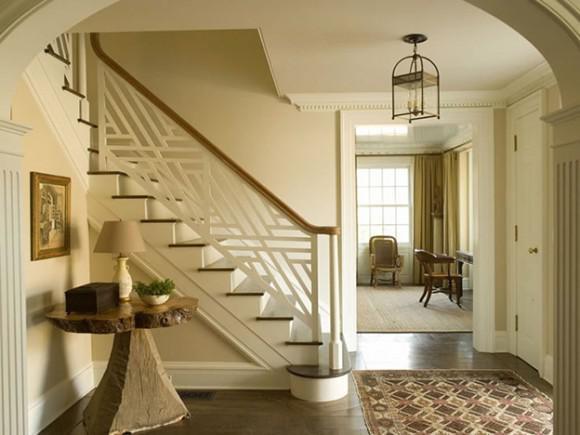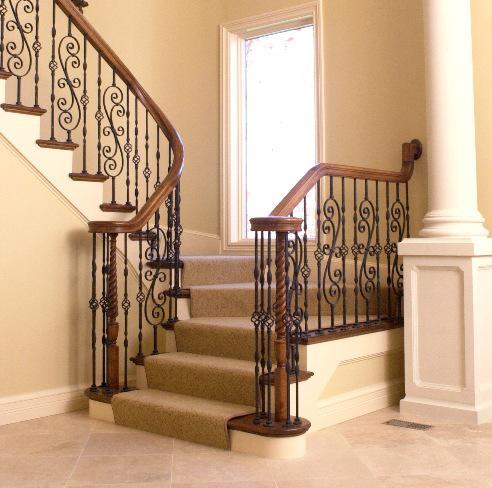The first image is the image on the left, the second image is the image on the right. Given the left and right images, does the statement "The left image shows a leftward ascending staircase with a wooden handrail and black wrought iron bars accented with overlapping scroll shapes." hold true? Answer yes or no. No. The first image is the image on the left, the second image is the image on the right. Given the left and right images, does the statement "The left and right image contains the same number of staircase with wooden and metal S shaped rails." hold true? Answer yes or no. No. 